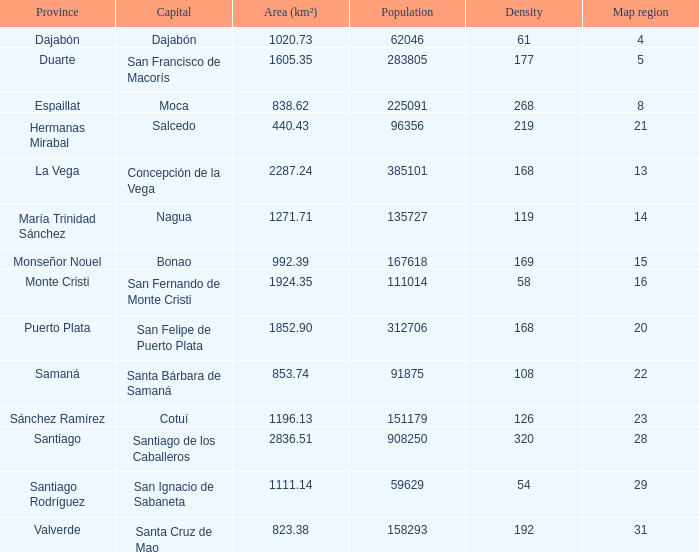When the province is monseñor nouel, what is the region's size (km²)? 992.39. Could you parse the entire table as a dict? {'header': ['Province', 'Capital', 'Area (km²)', 'Population', 'Density', 'Map region'], 'rows': [['Dajabón', 'Dajabón', '1020.73', '62046', '61', '4'], ['Duarte', 'San Francisco de Macorís', '1605.35', '283805', '177', '5'], ['Espaillat', 'Moca', '838.62', '225091', '268', '8'], ['Hermanas Mirabal', 'Salcedo', '440.43', '96356', '219', '21'], ['La Vega', 'Concepción de la Vega', '2287.24', '385101', '168', '13'], ['María Trinidad Sánchez', 'Nagua', '1271.71', '135727', '119', '14'], ['Monseñor Nouel', 'Bonao', '992.39', '167618', '169', '15'], ['Monte Cristi', 'San Fernando de Monte Cristi', '1924.35', '111014', '58', '16'], ['Puerto Plata', 'San Felipe de Puerto Plata', '1852.90', '312706', '168', '20'], ['Samaná', 'Santa Bárbara de Samaná', '853.74', '91875', '108', '22'], ['Sánchez Ramírez', 'Cotuí', '1196.13', '151179', '126', '23'], ['Santiago', 'Santiago de los Caballeros', '2836.51', '908250', '320', '28'], ['Santiago Rodríguez', 'San Ignacio de Sabaneta', '1111.14', '59629', '54', '29'], ['Valverde', 'Santa Cruz de Mao', '823.38', '158293', '192', '31']]} 